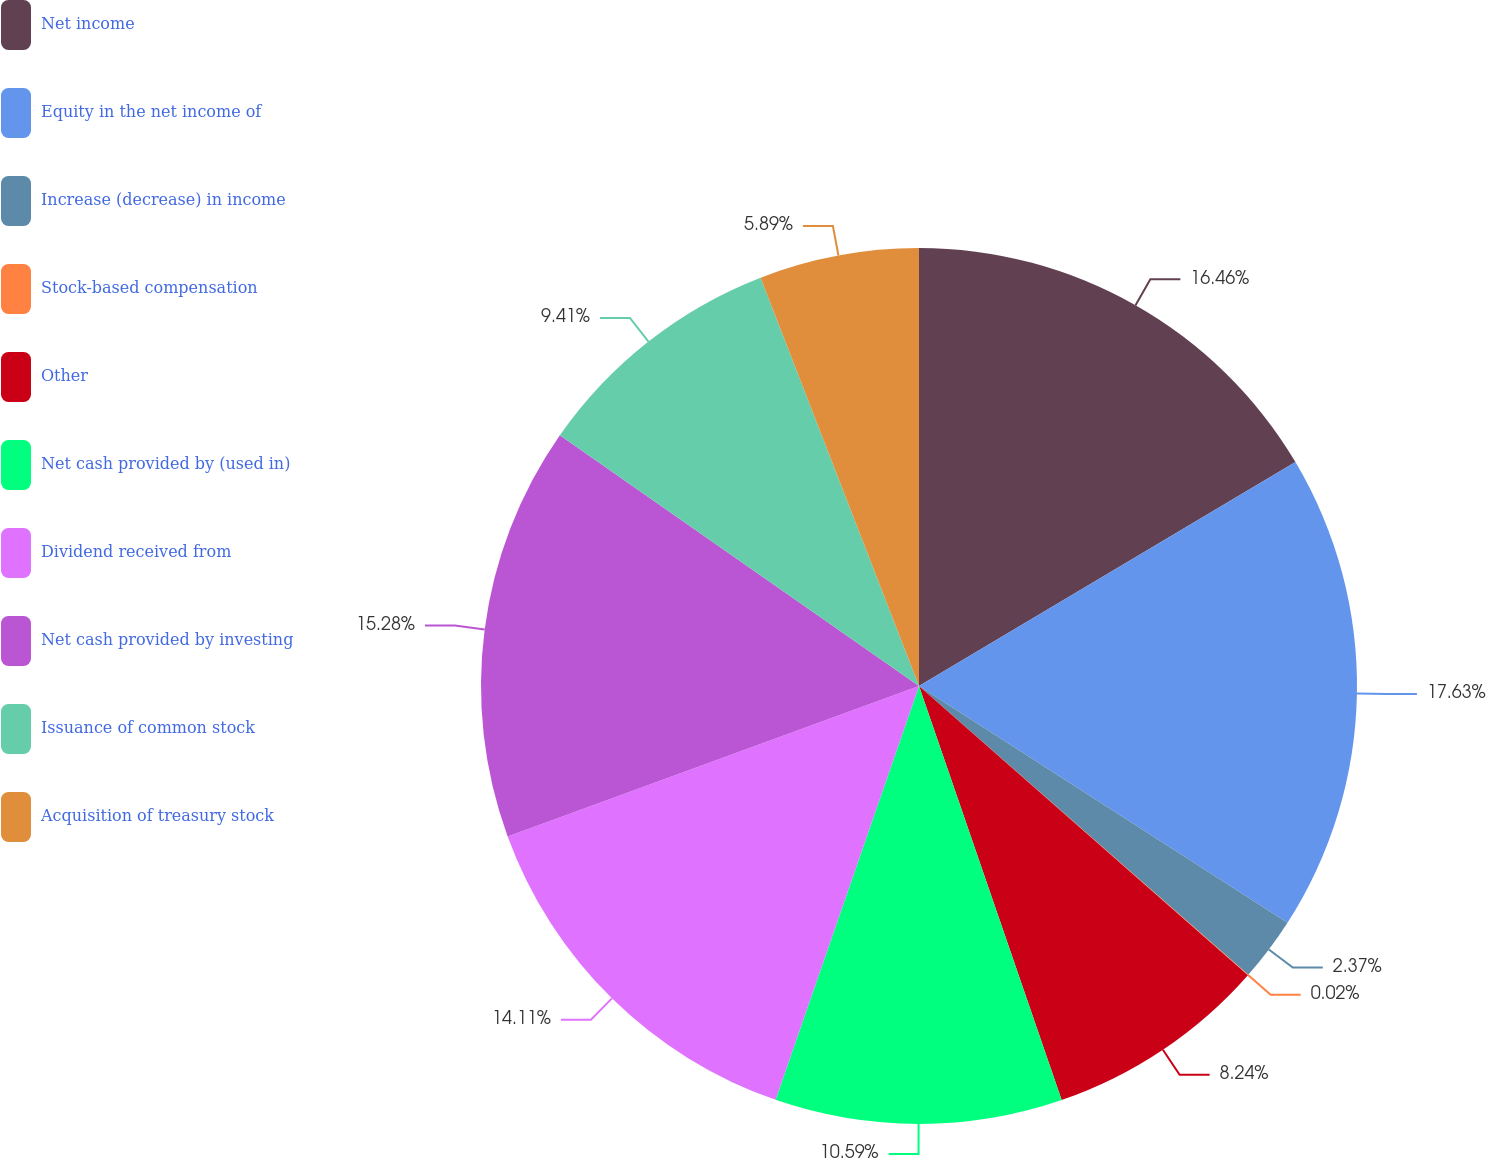<chart> <loc_0><loc_0><loc_500><loc_500><pie_chart><fcel>Net income<fcel>Equity in the net income of<fcel>Increase (decrease) in income<fcel>Stock-based compensation<fcel>Other<fcel>Net cash provided by (used in)<fcel>Dividend received from<fcel>Net cash provided by investing<fcel>Issuance of common stock<fcel>Acquisition of treasury stock<nl><fcel>16.46%<fcel>17.63%<fcel>2.37%<fcel>0.02%<fcel>8.24%<fcel>10.59%<fcel>14.11%<fcel>15.28%<fcel>9.41%<fcel>5.89%<nl></chart> 